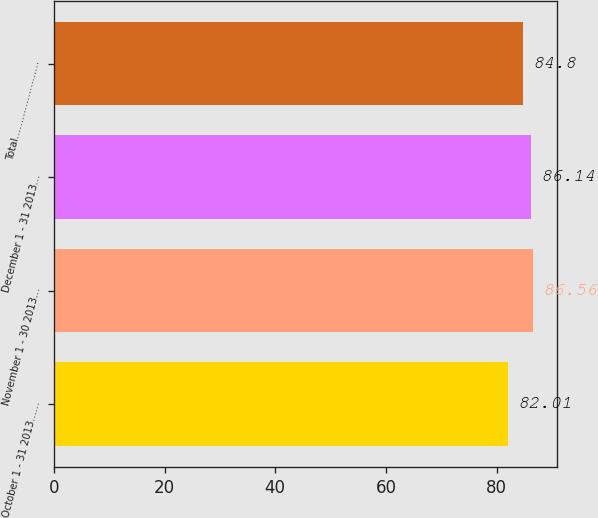<chart> <loc_0><loc_0><loc_500><loc_500><bar_chart><fcel>October 1 - 31 2013……<fcel>November 1 - 30 2013…<fcel>December 1 - 31 2013…<fcel>Total……………………<nl><fcel>82.01<fcel>86.56<fcel>86.14<fcel>84.8<nl></chart> 